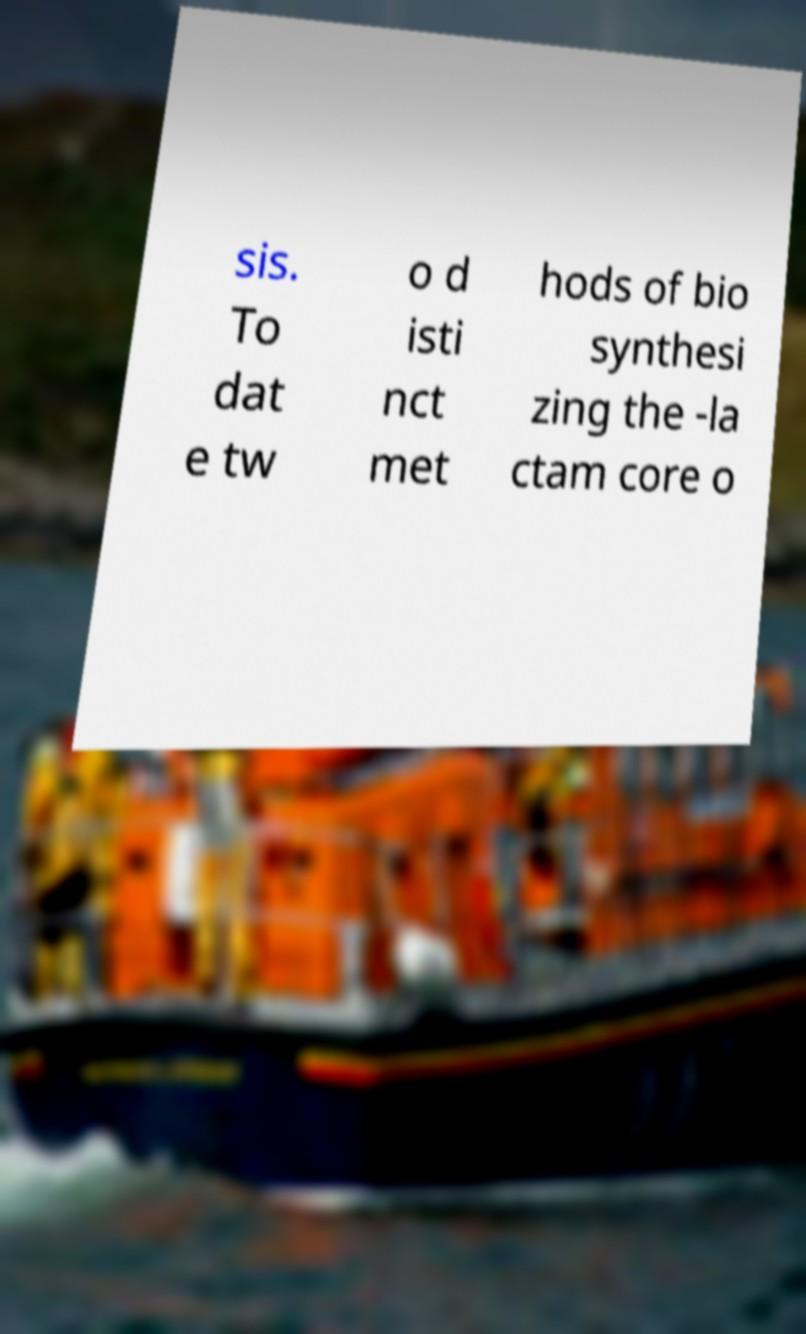What messages or text are displayed in this image? I need them in a readable, typed format. sis. To dat e tw o d isti nct met hods of bio synthesi zing the -la ctam core o 